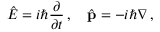<formula> <loc_0><loc_0><loc_500><loc_500>{ \hat { E } } = i \hbar { \frac { \partial } { \partial t } } \, , \quad \hat { p } = - i \hbar { \nabla } \, ,</formula> 